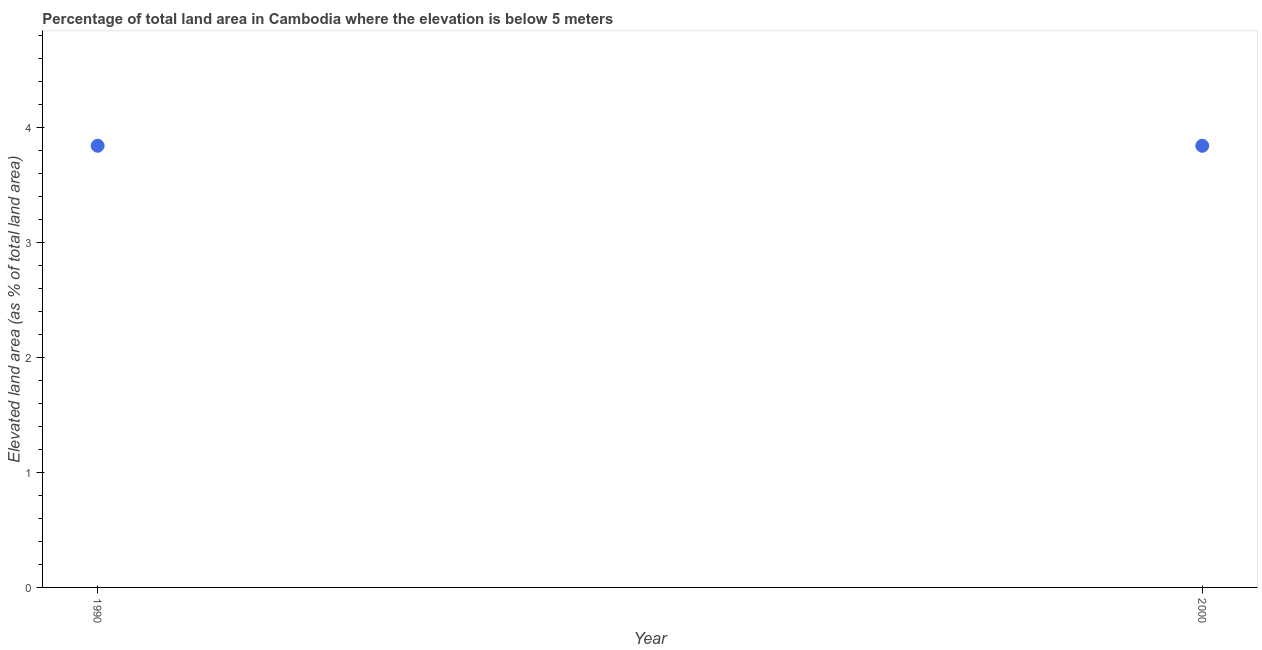What is the total elevated land area in 1990?
Provide a succinct answer. 3.84. Across all years, what is the maximum total elevated land area?
Offer a terse response. 3.84. Across all years, what is the minimum total elevated land area?
Ensure brevity in your answer.  3.84. What is the sum of the total elevated land area?
Ensure brevity in your answer.  7.68. What is the difference between the total elevated land area in 1990 and 2000?
Ensure brevity in your answer.  0. What is the average total elevated land area per year?
Offer a terse response. 3.84. What is the median total elevated land area?
Keep it short and to the point. 3.84. In how many years, is the total elevated land area greater than 2.8 %?
Your response must be concise. 2. In how many years, is the total elevated land area greater than the average total elevated land area taken over all years?
Provide a short and direct response. 0. How many dotlines are there?
Keep it short and to the point. 1. What is the difference between two consecutive major ticks on the Y-axis?
Your answer should be compact. 1. Does the graph contain any zero values?
Your answer should be compact. No. What is the title of the graph?
Ensure brevity in your answer.  Percentage of total land area in Cambodia where the elevation is below 5 meters. What is the label or title of the X-axis?
Give a very brief answer. Year. What is the label or title of the Y-axis?
Provide a short and direct response. Elevated land area (as % of total land area). What is the Elevated land area (as % of total land area) in 1990?
Offer a very short reply. 3.84. What is the Elevated land area (as % of total land area) in 2000?
Ensure brevity in your answer.  3.84. What is the difference between the Elevated land area (as % of total land area) in 1990 and 2000?
Ensure brevity in your answer.  0. 